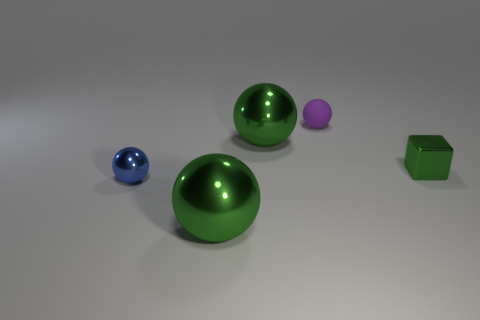Subtract all red blocks. Subtract all green cylinders. How many blocks are left? 1 Add 3 big yellow cylinders. How many objects exist? 8 Subtract all blocks. How many objects are left? 4 Subtract all tiny cylinders. Subtract all blue things. How many objects are left? 4 Add 5 tiny blue spheres. How many tiny blue spheres are left? 6 Add 5 rubber balls. How many rubber balls exist? 6 Subtract 0 cyan cubes. How many objects are left? 5 